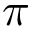<formula> <loc_0><loc_0><loc_500><loc_500>\pi</formula> 